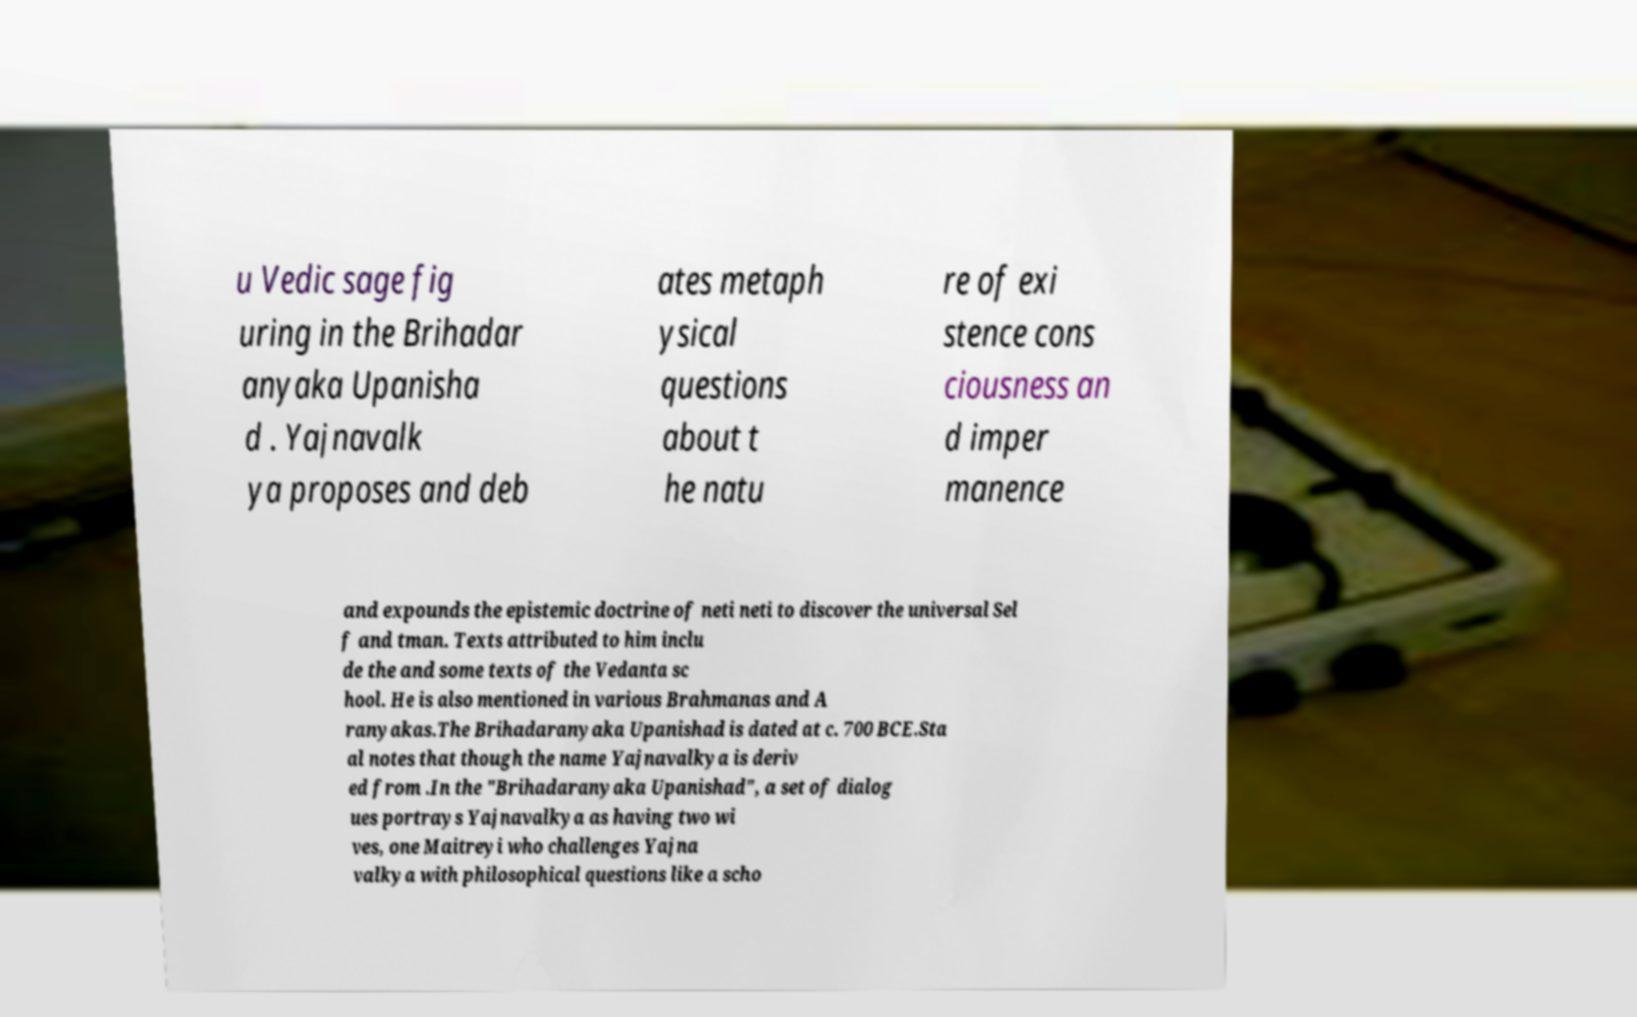Can you read and provide the text displayed in the image?This photo seems to have some interesting text. Can you extract and type it out for me? u Vedic sage fig uring in the Brihadar anyaka Upanisha d . Yajnavalk ya proposes and deb ates metaph ysical questions about t he natu re of exi stence cons ciousness an d imper manence and expounds the epistemic doctrine of neti neti to discover the universal Sel f and tman. Texts attributed to him inclu de the and some texts of the Vedanta sc hool. He is also mentioned in various Brahmanas and A ranyakas.The Brihadaranyaka Upanishad is dated at c. 700 BCE.Sta al notes that though the name Yajnavalkya is deriv ed from .In the "Brihadaranyaka Upanishad", a set of dialog ues portrays Yajnavalkya as having two wi ves, one Maitreyi who challenges Yajna valkya with philosophical questions like a scho 